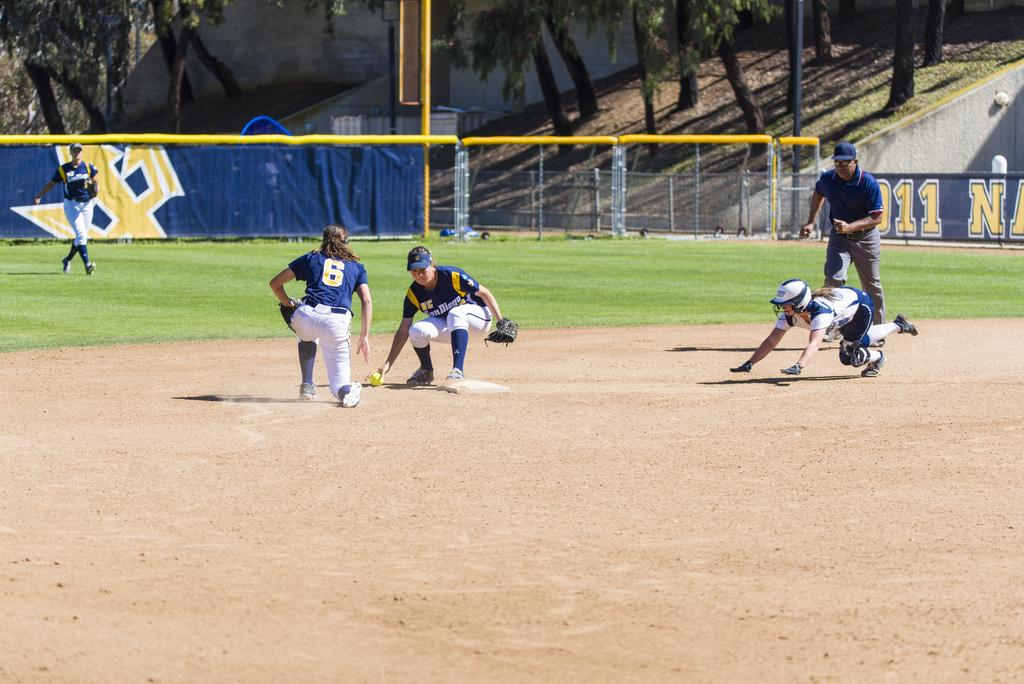<image>
Give a short and clear explanation of the subsequent image. A San Diego girls softball team is in the middle of a game on a bright sunny day. 